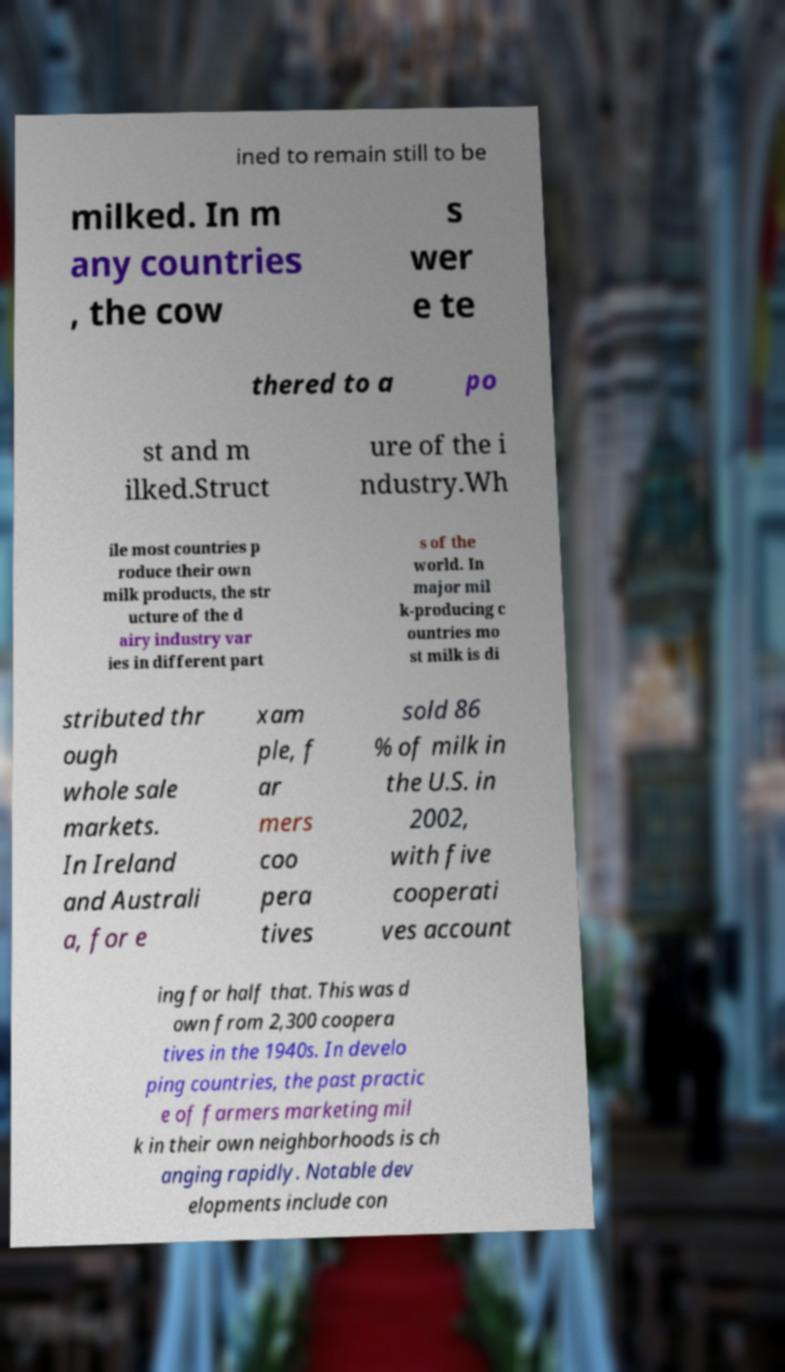Can you read and provide the text displayed in the image?This photo seems to have some interesting text. Can you extract and type it out for me? ined to remain still to be milked. In m any countries , the cow s wer e te thered to a po st and m ilked.Struct ure of the i ndustry.Wh ile most countries p roduce their own milk products, the str ucture of the d airy industry var ies in different part s of the world. In major mil k-producing c ountries mo st milk is di stributed thr ough whole sale markets. In Ireland and Australi a, for e xam ple, f ar mers coo pera tives sold 86 % of milk in the U.S. in 2002, with five cooperati ves account ing for half that. This was d own from 2,300 coopera tives in the 1940s. In develo ping countries, the past practic e of farmers marketing mil k in their own neighborhoods is ch anging rapidly. Notable dev elopments include con 